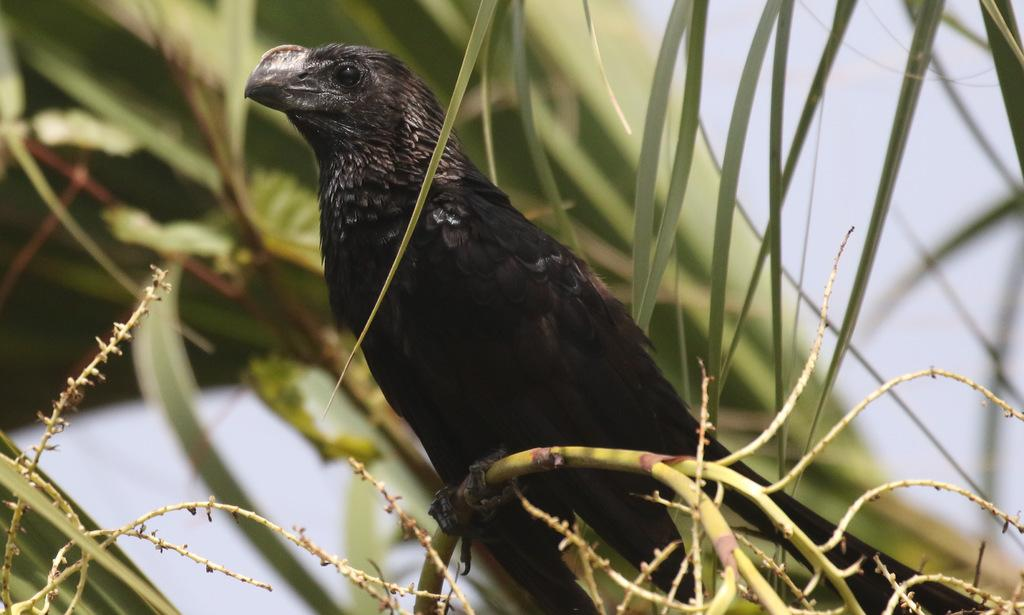What type of bird can be seen in the image? There is a black color bird standing in the image. What else is present in the image besides the bird? Leaves are visible in the image. How would you describe the background of the image? The background of the image is blurry. Are there any leaves in the background of the image? Yes, there are leaves in the background of the image. What type of force is being applied to the train in the image? There is no train present in the image, so it is not possible to determine if any force is being applied. 